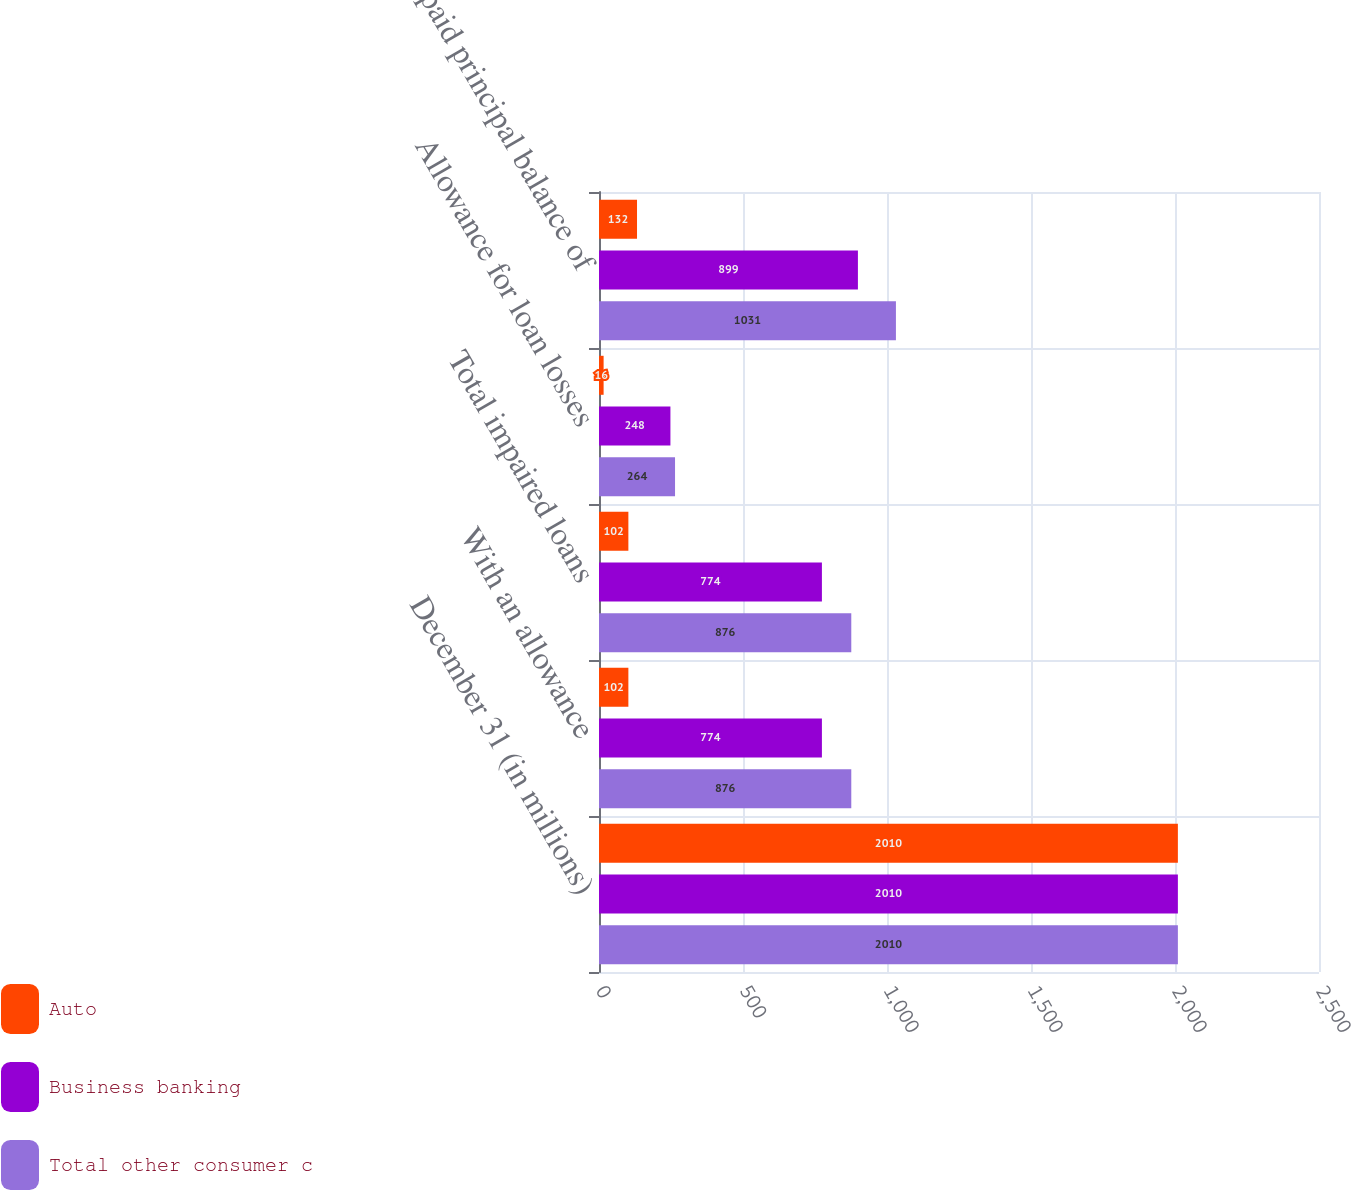<chart> <loc_0><loc_0><loc_500><loc_500><stacked_bar_chart><ecel><fcel>December 31 (in millions)<fcel>With an allowance<fcel>Total impaired loans<fcel>Allowance for loan losses<fcel>Unpaid principal balance of<nl><fcel>Auto<fcel>2010<fcel>102<fcel>102<fcel>16<fcel>132<nl><fcel>Business banking<fcel>2010<fcel>774<fcel>774<fcel>248<fcel>899<nl><fcel>Total other consumer c<fcel>2010<fcel>876<fcel>876<fcel>264<fcel>1031<nl></chart> 